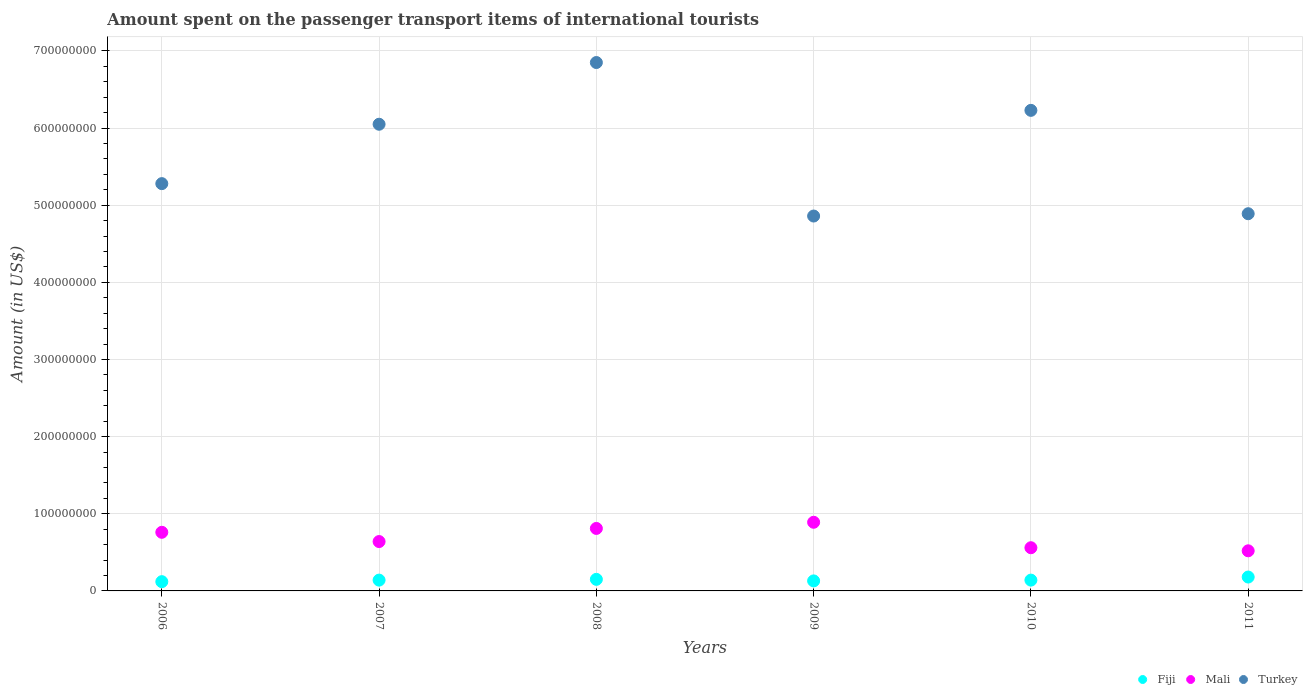What is the amount spent on the passenger transport items of international tourists in Fiji in 2006?
Provide a short and direct response. 1.20e+07. Across all years, what is the maximum amount spent on the passenger transport items of international tourists in Mali?
Your answer should be very brief. 8.90e+07. Across all years, what is the minimum amount spent on the passenger transport items of international tourists in Fiji?
Provide a short and direct response. 1.20e+07. In which year was the amount spent on the passenger transport items of international tourists in Turkey minimum?
Give a very brief answer. 2009. What is the total amount spent on the passenger transport items of international tourists in Fiji in the graph?
Your response must be concise. 8.60e+07. What is the difference between the amount spent on the passenger transport items of international tourists in Mali in 2008 and that in 2009?
Offer a very short reply. -8.00e+06. What is the difference between the amount spent on the passenger transport items of international tourists in Turkey in 2008 and the amount spent on the passenger transport items of international tourists in Mali in 2007?
Keep it short and to the point. 6.21e+08. What is the average amount spent on the passenger transport items of international tourists in Mali per year?
Offer a very short reply. 6.97e+07. In the year 2009, what is the difference between the amount spent on the passenger transport items of international tourists in Turkey and amount spent on the passenger transport items of international tourists in Mali?
Your response must be concise. 3.97e+08. What is the ratio of the amount spent on the passenger transport items of international tourists in Turkey in 2008 to that in 2010?
Your answer should be compact. 1.1. Is the amount spent on the passenger transport items of international tourists in Fiji in 2007 less than that in 2009?
Give a very brief answer. No. What is the difference between the highest and the second highest amount spent on the passenger transport items of international tourists in Turkey?
Give a very brief answer. 6.20e+07. What is the difference between the highest and the lowest amount spent on the passenger transport items of international tourists in Fiji?
Keep it short and to the point. 6.00e+06. Is it the case that in every year, the sum of the amount spent on the passenger transport items of international tourists in Mali and amount spent on the passenger transport items of international tourists in Turkey  is greater than the amount spent on the passenger transport items of international tourists in Fiji?
Offer a very short reply. Yes. Does the amount spent on the passenger transport items of international tourists in Turkey monotonically increase over the years?
Give a very brief answer. No. How many years are there in the graph?
Keep it short and to the point. 6. What is the title of the graph?
Offer a terse response. Amount spent on the passenger transport items of international tourists. Does "Ghana" appear as one of the legend labels in the graph?
Your response must be concise. No. What is the label or title of the X-axis?
Your answer should be very brief. Years. What is the label or title of the Y-axis?
Provide a succinct answer. Amount (in US$). What is the Amount (in US$) in Mali in 2006?
Your response must be concise. 7.60e+07. What is the Amount (in US$) of Turkey in 2006?
Provide a succinct answer. 5.28e+08. What is the Amount (in US$) of Fiji in 2007?
Offer a terse response. 1.40e+07. What is the Amount (in US$) of Mali in 2007?
Keep it short and to the point. 6.40e+07. What is the Amount (in US$) in Turkey in 2007?
Ensure brevity in your answer.  6.05e+08. What is the Amount (in US$) in Fiji in 2008?
Your answer should be very brief. 1.50e+07. What is the Amount (in US$) of Mali in 2008?
Provide a succinct answer. 8.10e+07. What is the Amount (in US$) of Turkey in 2008?
Provide a short and direct response. 6.85e+08. What is the Amount (in US$) of Fiji in 2009?
Give a very brief answer. 1.30e+07. What is the Amount (in US$) of Mali in 2009?
Your response must be concise. 8.90e+07. What is the Amount (in US$) in Turkey in 2009?
Offer a terse response. 4.86e+08. What is the Amount (in US$) in Fiji in 2010?
Your answer should be compact. 1.40e+07. What is the Amount (in US$) in Mali in 2010?
Give a very brief answer. 5.60e+07. What is the Amount (in US$) in Turkey in 2010?
Ensure brevity in your answer.  6.23e+08. What is the Amount (in US$) of Fiji in 2011?
Your answer should be very brief. 1.80e+07. What is the Amount (in US$) in Mali in 2011?
Keep it short and to the point. 5.20e+07. What is the Amount (in US$) in Turkey in 2011?
Give a very brief answer. 4.89e+08. Across all years, what is the maximum Amount (in US$) in Fiji?
Keep it short and to the point. 1.80e+07. Across all years, what is the maximum Amount (in US$) in Mali?
Keep it short and to the point. 8.90e+07. Across all years, what is the maximum Amount (in US$) of Turkey?
Make the answer very short. 6.85e+08. Across all years, what is the minimum Amount (in US$) in Fiji?
Provide a succinct answer. 1.20e+07. Across all years, what is the minimum Amount (in US$) in Mali?
Your answer should be very brief. 5.20e+07. Across all years, what is the minimum Amount (in US$) of Turkey?
Provide a succinct answer. 4.86e+08. What is the total Amount (in US$) of Fiji in the graph?
Provide a short and direct response. 8.60e+07. What is the total Amount (in US$) in Mali in the graph?
Your answer should be very brief. 4.18e+08. What is the total Amount (in US$) of Turkey in the graph?
Provide a succinct answer. 3.42e+09. What is the difference between the Amount (in US$) in Mali in 2006 and that in 2007?
Provide a succinct answer. 1.20e+07. What is the difference between the Amount (in US$) in Turkey in 2006 and that in 2007?
Provide a short and direct response. -7.70e+07. What is the difference between the Amount (in US$) of Mali in 2006 and that in 2008?
Ensure brevity in your answer.  -5.00e+06. What is the difference between the Amount (in US$) in Turkey in 2006 and that in 2008?
Ensure brevity in your answer.  -1.57e+08. What is the difference between the Amount (in US$) in Fiji in 2006 and that in 2009?
Keep it short and to the point. -1.00e+06. What is the difference between the Amount (in US$) in Mali in 2006 and that in 2009?
Keep it short and to the point. -1.30e+07. What is the difference between the Amount (in US$) in Turkey in 2006 and that in 2009?
Your answer should be compact. 4.20e+07. What is the difference between the Amount (in US$) of Mali in 2006 and that in 2010?
Provide a short and direct response. 2.00e+07. What is the difference between the Amount (in US$) of Turkey in 2006 and that in 2010?
Provide a short and direct response. -9.50e+07. What is the difference between the Amount (in US$) of Fiji in 2006 and that in 2011?
Keep it short and to the point. -6.00e+06. What is the difference between the Amount (in US$) of Mali in 2006 and that in 2011?
Keep it short and to the point. 2.40e+07. What is the difference between the Amount (in US$) in Turkey in 2006 and that in 2011?
Provide a short and direct response. 3.90e+07. What is the difference between the Amount (in US$) of Mali in 2007 and that in 2008?
Provide a short and direct response. -1.70e+07. What is the difference between the Amount (in US$) of Turkey in 2007 and that in 2008?
Offer a terse response. -8.00e+07. What is the difference between the Amount (in US$) of Mali in 2007 and that in 2009?
Provide a succinct answer. -2.50e+07. What is the difference between the Amount (in US$) of Turkey in 2007 and that in 2009?
Offer a very short reply. 1.19e+08. What is the difference between the Amount (in US$) in Fiji in 2007 and that in 2010?
Make the answer very short. 0. What is the difference between the Amount (in US$) in Turkey in 2007 and that in 2010?
Make the answer very short. -1.80e+07. What is the difference between the Amount (in US$) of Mali in 2007 and that in 2011?
Make the answer very short. 1.20e+07. What is the difference between the Amount (in US$) in Turkey in 2007 and that in 2011?
Offer a very short reply. 1.16e+08. What is the difference between the Amount (in US$) in Fiji in 2008 and that in 2009?
Ensure brevity in your answer.  2.00e+06. What is the difference between the Amount (in US$) of Mali in 2008 and that in 2009?
Keep it short and to the point. -8.00e+06. What is the difference between the Amount (in US$) of Turkey in 2008 and that in 2009?
Give a very brief answer. 1.99e+08. What is the difference between the Amount (in US$) of Mali in 2008 and that in 2010?
Keep it short and to the point. 2.50e+07. What is the difference between the Amount (in US$) in Turkey in 2008 and that in 2010?
Your answer should be compact. 6.20e+07. What is the difference between the Amount (in US$) of Mali in 2008 and that in 2011?
Offer a terse response. 2.90e+07. What is the difference between the Amount (in US$) in Turkey in 2008 and that in 2011?
Keep it short and to the point. 1.96e+08. What is the difference between the Amount (in US$) in Mali in 2009 and that in 2010?
Keep it short and to the point. 3.30e+07. What is the difference between the Amount (in US$) in Turkey in 2009 and that in 2010?
Your answer should be very brief. -1.37e+08. What is the difference between the Amount (in US$) of Fiji in 2009 and that in 2011?
Provide a succinct answer. -5.00e+06. What is the difference between the Amount (in US$) of Mali in 2009 and that in 2011?
Your response must be concise. 3.70e+07. What is the difference between the Amount (in US$) of Fiji in 2010 and that in 2011?
Offer a terse response. -4.00e+06. What is the difference between the Amount (in US$) of Turkey in 2010 and that in 2011?
Your response must be concise. 1.34e+08. What is the difference between the Amount (in US$) of Fiji in 2006 and the Amount (in US$) of Mali in 2007?
Provide a succinct answer. -5.20e+07. What is the difference between the Amount (in US$) in Fiji in 2006 and the Amount (in US$) in Turkey in 2007?
Provide a short and direct response. -5.93e+08. What is the difference between the Amount (in US$) in Mali in 2006 and the Amount (in US$) in Turkey in 2007?
Make the answer very short. -5.29e+08. What is the difference between the Amount (in US$) in Fiji in 2006 and the Amount (in US$) in Mali in 2008?
Your answer should be compact. -6.90e+07. What is the difference between the Amount (in US$) of Fiji in 2006 and the Amount (in US$) of Turkey in 2008?
Offer a very short reply. -6.73e+08. What is the difference between the Amount (in US$) in Mali in 2006 and the Amount (in US$) in Turkey in 2008?
Offer a very short reply. -6.09e+08. What is the difference between the Amount (in US$) of Fiji in 2006 and the Amount (in US$) of Mali in 2009?
Provide a succinct answer. -7.70e+07. What is the difference between the Amount (in US$) in Fiji in 2006 and the Amount (in US$) in Turkey in 2009?
Offer a terse response. -4.74e+08. What is the difference between the Amount (in US$) of Mali in 2006 and the Amount (in US$) of Turkey in 2009?
Give a very brief answer. -4.10e+08. What is the difference between the Amount (in US$) in Fiji in 2006 and the Amount (in US$) in Mali in 2010?
Provide a short and direct response. -4.40e+07. What is the difference between the Amount (in US$) in Fiji in 2006 and the Amount (in US$) in Turkey in 2010?
Make the answer very short. -6.11e+08. What is the difference between the Amount (in US$) of Mali in 2006 and the Amount (in US$) of Turkey in 2010?
Provide a succinct answer. -5.47e+08. What is the difference between the Amount (in US$) in Fiji in 2006 and the Amount (in US$) in Mali in 2011?
Your answer should be very brief. -4.00e+07. What is the difference between the Amount (in US$) in Fiji in 2006 and the Amount (in US$) in Turkey in 2011?
Give a very brief answer. -4.77e+08. What is the difference between the Amount (in US$) of Mali in 2006 and the Amount (in US$) of Turkey in 2011?
Keep it short and to the point. -4.13e+08. What is the difference between the Amount (in US$) of Fiji in 2007 and the Amount (in US$) of Mali in 2008?
Offer a very short reply. -6.70e+07. What is the difference between the Amount (in US$) in Fiji in 2007 and the Amount (in US$) in Turkey in 2008?
Offer a terse response. -6.71e+08. What is the difference between the Amount (in US$) of Mali in 2007 and the Amount (in US$) of Turkey in 2008?
Ensure brevity in your answer.  -6.21e+08. What is the difference between the Amount (in US$) of Fiji in 2007 and the Amount (in US$) of Mali in 2009?
Ensure brevity in your answer.  -7.50e+07. What is the difference between the Amount (in US$) in Fiji in 2007 and the Amount (in US$) in Turkey in 2009?
Your response must be concise. -4.72e+08. What is the difference between the Amount (in US$) of Mali in 2007 and the Amount (in US$) of Turkey in 2009?
Make the answer very short. -4.22e+08. What is the difference between the Amount (in US$) in Fiji in 2007 and the Amount (in US$) in Mali in 2010?
Your response must be concise. -4.20e+07. What is the difference between the Amount (in US$) of Fiji in 2007 and the Amount (in US$) of Turkey in 2010?
Make the answer very short. -6.09e+08. What is the difference between the Amount (in US$) of Mali in 2007 and the Amount (in US$) of Turkey in 2010?
Give a very brief answer. -5.59e+08. What is the difference between the Amount (in US$) of Fiji in 2007 and the Amount (in US$) of Mali in 2011?
Your answer should be compact. -3.80e+07. What is the difference between the Amount (in US$) of Fiji in 2007 and the Amount (in US$) of Turkey in 2011?
Provide a succinct answer. -4.75e+08. What is the difference between the Amount (in US$) in Mali in 2007 and the Amount (in US$) in Turkey in 2011?
Offer a very short reply. -4.25e+08. What is the difference between the Amount (in US$) in Fiji in 2008 and the Amount (in US$) in Mali in 2009?
Your answer should be compact. -7.40e+07. What is the difference between the Amount (in US$) in Fiji in 2008 and the Amount (in US$) in Turkey in 2009?
Ensure brevity in your answer.  -4.71e+08. What is the difference between the Amount (in US$) in Mali in 2008 and the Amount (in US$) in Turkey in 2009?
Your answer should be very brief. -4.05e+08. What is the difference between the Amount (in US$) in Fiji in 2008 and the Amount (in US$) in Mali in 2010?
Make the answer very short. -4.10e+07. What is the difference between the Amount (in US$) of Fiji in 2008 and the Amount (in US$) of Turkey in 2010?
Give a very brief answer. -6.08e+08. What is the difference between the Amount (in US$) in Mali in 2008 and the Amount (in US$) in Turkey in 2010?
Provide a succinct answer. -5.42e+08. What is the difference between the Amount (in US$) in Fiji in 2008 and the Amount (in US$) in Mali in 2011?
Make the answer very short. -3.70e+07. What is the difference between the Amount (in US$) in Fiji in 2008 and the Amount (in US$) in Turkey in 2011?
Ensure brevity in your answer.  -4.74e+08. What is the difference between the Amount (in US$) of Mali in 2008 and the Amount (in US$) of Turkey in 2011?
Offer a very short reply. -4.08e+08. What is the difference between the Amount (in US$) in Fiji in 2009 and the Amount (in US$) in Mali in 2010?
Your response must be concise. -4.30e+07. What is the difference between the Amount (in US$) in Fiji in 2009 and the Amount (in US$) in Turkey in 2010?
Give a very brief answer. -6.10e+08. What is the difference between the Amount (in US$) of Mali in 2009 and the Amount (in US$) of Turkey in 2010?
Offer a terse response. -5.34e+08. What is the difference between the Amount (in US$) of Fiji in 2009 and the Amount (in US$) of Mali in 2011?
Provide a short and direct response. -3.90e+07. What is the difference between the Amount (in US$) in Fiji in 2009 and the Amount (in US$) in Turkey in 2011?
Provide a succinct answer. -4.76e+08. What is the difference between the Amount (in US$) in Mali in 2009 and the Amount (in US$) in Turkey in 2011?
Give a very brief answer. -4.00e+08. What is the difference between the Amount (in US$) of Fiji in 2010 and the Amount (in US$) of Mali in 2011?
Offer a terse response. -3.80e+07. What is the difference between the Amount (in US$) of Fiji in 2010 and the Amount (in US$) of Turkey in 2011?
Give a very brief answer. -4.75e+08. What is the difference between the Amount (in US$) in Mali in 2010 and the Amount (in US$) in Turkey in 2011?
Your response must be concise. -4.33e+08. What is the average Amount (in US$) in Fiji per year?
Your response must be concise. 1.43e+07. What is the average Amount (in US$) in Mali per year?
Provide a short and direct response. 6.97e+07. What is the average Amount (in US$) in Turkey per year?
Offer a terse response. 5.69e+08. In the year 2006, what is the difference between the Amount (in US$) in Fiji and Amount (in US$) in Mali?
Provide a short and direct response. -6.40e+07. In the year 2006, what is the difference between the Amount (in US$) in Fiji and Amount (in US$) in Turkey?
Provide a short and direct response. -5.16e+08. In the year 2006, what is the difference between the Amount (in US$) in Mali and Amount (in US$) in Turkey?
Offer a terse response. -4.52e+08. In the year 2007, what is the difference between the Amount (in US$) in Fiji and Amount (in US$) in Mali?
Offer a terse response. -5.00e+07. In the year 2007, what is the difference between the Amount (in US$) of Fiji and Amount (in US$) of Turkey?
Your response must be concise. -5.91e+08. In the year 2007, what is the difference between the Amount (in US$) in Mali and Amount (in US$) in Turkey?
Provide a short and direct response. -5.41e+08. In the year 2008, what is the difference between the Amount (in US$) of Fiji and Amount (in US$) of Mali?
Give a very brief answer. -6.60e+07. In the year 2008, what is the difference between the Amount (in US$) in Fiji and Amount (in US$) in Turkey?
Your answer should be compact. -6.70e+08. In the year 2008, what is the difference between the Amount (in US$) of Mali and Amount (in US$) of Turkey?
Your answer should be compact. -6.04e+08. In the year 2009, what is the difference between the Amount (in US$) of Fiji and Amount (in US$) of Mali?
Make the answer very short. -7.60e+07. In the year 2009, what is the difference between the Amount (in US$) in Fiji and Amount (in US$) in Turkey?
Your answer should be very brief. -4.73e+08. In the year 2009, what is the difference between the Amount (in US$) in Mali and Amount (in US$) in Turkey?
Offer a terse response. -3.97e+08. In the year 2010, what is the difference between the Amount (in US$) in Fiji and Amount (in US$) in Mali?
Provide a short and direct response. -4.20e+07. In the year 2010, what is the difference between the Amount (in US$) in Fiji and Amount (in US$) in Turkey?
Provide a succinct answer. -6.09e+08. In the year 2010, what is the difference between the Amount (in US$) of Mali and Amount (in US$) of Turkey?
Your response must be concise. -5.67e+08. In the year 2011, what is the difference between the Amount (in US$) of Fiji and Amount (in US$) of Mali?
Your answer should be very brief. -3.40e+07. In the year 2011, what is the difference between the Amount (in US$) of Fiji and Amount (in US$) of Turkey?
Your response must be concise. -4.71e+08. In the year 2011, what is the difference between the Amount (in US$) of Mali and Amount (in US$) of Turkey?
Provide a short and direct response. -4.37e+08. What is the ratio of the Amount (in US$) of Mali in 2006 to that in 2007?
Your answer should be compact. 1.19. What is the ratio of the Amount (in US$) in Turkey in 2006 to that in 2007?
Your answer should be very brief. 0.87. What is the ratio of the Amount (in US$) in Fiji in 2006 to that in 2008?
Give a very brief answer. 0.8. What is the ratio of the Amount (in US$) of Mali in 2006 to that in 2008?
Your answer should be compact. 0.94. What is the ratio of the Amount (in US$) in Turkey in 2006 to that in 2008?
Offer a very short reply. 0.77. What is the ratio of the Amount (in US$) in Mali in 2006 to that in 2009?
Keep it short and to the point. 0.85. What is the ratio of the Amount (in US$) in Turkey in 2006 to that in 2009?
Offer a terse response. 1.09. What is the ratio of the Amount (in US$) of Fiji in 2006 to that in 2010?
Provide a short and direct response. 0.86. What is the ratio of the Amount (in US$) of Mali in 2006 to that in 2010?
Offer a terse response. 1.36. What is the ratio of the Amount (in US$) in Turkey in 2006 to that in 2010?
Give a very brief answer. 0.85. What is the ratio of the Amount (in US$) of Mali in 2006 to that in 2011?
Keep it short and to the point. 1.46. What is the ratio of the Amount (in US$) in Turkey in 2006 to that in 2011?
Your answer should be very brief. 1.08. What is the ratio of the Amount (in US$) of Mali in 2007 to that in 2008?
Offer a terse response. 0.79. What is the ratio of the Amount (in US$) of Turkey in 2007 to that in 2008?
Your answer should be very brief. 0.88. What is the ratio of the Amount (in US$) of Mali in 2007 to that in 2009?
Provide a short and direct response. 0.72. What is the ratio of the Amount (in US$) of Turkey in 2007 to that in 2009?
Give a very brief answer. 1.24. What is the ratio of the Amount (in US$) of Mali in 2007 to that in 2010?
Keep it short and to the point. 1.14. What is the ratio of the Amount (in US$) in Turkey in 2007 to that in 2010?
Offer a terse response. 0.97. What is the ratio of the Amount (in US$) in Mali in 2007 to that in 2011?
Offer a terse response. 1.23. What is the ratio of the Amount (in US$) in Turkey in 2007 to that in 2011?
Give a very brief answer. 1.24. What is the ratio of the Amount (in US$) of Fiji in 2008 to that in 2009?
Your answer should be compact. 1.15. What is the ratio of the Amount (in US$) of Mali in 2008 to that in 2009?
Give a very brief answer. 0.91. What is the ratio of the Amount (in US$) in Turkey in 2008 to that in 2009?
Make the answer very short. 1.41. What is the ratio of the Amount (in US$) of Fiji in 2008 to that in 2010?
Keep it short and to the point. 1.07. What is the ratio of the Amount (in US$) in Mali in 2008 to that in 2010?
Give a very brief answer. 1.45. What is the ratio of the Amount (in US$) in Turkey in 2008 to that in 2010?
Keep it short and to the point. 1.1. What is the ratio of the Amount (in US$) in Fiji in 2008 to that in 2011?
Keep it short and to the point. 0.83. What is the ratio of the Amount (in US$) in Mali in 2008 to that in 2011?
Your response must be concise. 1.56. What is the ratio of the Amount (in US$) of Turkey in 2008 to that in 2011?
Keep it short and to the point. 1.4. What is the ratio of the Amount (in US$) of Mali in 2009 to that in 2010?
Your response must be concise. 1.59. What is the ratio of the Amount (in US$) of Turkey in 2009 to that in 2010?
Provide a succinct answer. 0.78. What is the ratio of the Amount (in US$) of Fiji in 2009 to that in 2011?
Ensure brevity in your answer.  0.72. What is the ratio of the Amount (in US$) of Mali in 2009 to that in 2011?
Provide a short and direct response. 1.71. What is the ratio of the Amount (in US$) in Fiji in 2010 to that in 2011?
Your response must be concise. 0.78. What is the ratio of the Amount (in US$) of Mali in 2010 to that in 2011?
Your response must be concise. 1.08. What is the ratio of the Amount (in US$) of Turkey in 2010 to that in 2011?
Keep it short and to the point. 1.27. What is the difference between the highest and the second highest Amount (in US$) of Fiji?
Offer a terse response. 3.00e+06. What is the difference between the highest and the second highest Amount (in US$) in Mali?
Your answer should be compact. 8.00e+06. What is the difference between the highest and the second highest Amount (in US$) of Turkey?
Your answer should be very brief. 6.20e+07. What is the difference between the highest and the lowest Amount (in US$) of Mali?
Offer a terse response. 3.70e+07. What is the difference between the highest and the lowest Amount (in US$) in Turkey?
Offer a terse response. 1.99e+08. 